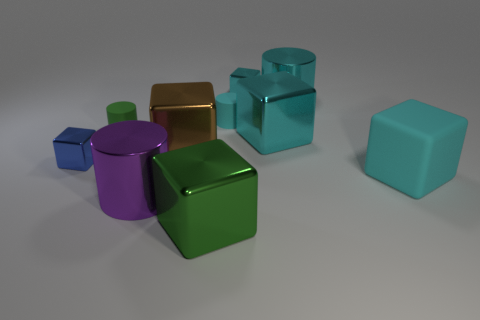Is the number of large metal cubes that are right of the green metal thing greater than the number of brown blocks behind the brown metallic object?
Your answer should be compact. Yes. There is a rubber cylinder that is the same color as the big rubber thing; what is its size?
Your answer should be compact. Small. Do the green cube and the cyan block in front of the brown metal block have the same size?
Your answer should be very brief. Yes. What number of cylinders are cyan metal things or big matte things?
Make the answer very short. 1. There is a blue object that is made of the same material as the purple cylinder; what is its size?
Offer a terse response. Small. Is the size of the cyan rubber object that is behind the big matte cube the same as the matte cylinder on the left side of the big brown block?
Keep it short and to the point. Yes. How many objects are big cyan cylinders or metallic blocks?
Provide a succinct answer. 6. There is a blue metal object; what shape is it?
Your answer should be compact. Cube. The cyan rubber object that is the same shape as the small green thing is what size?
Provide a succinct answer. Small. How big is the metallic thing left of the shiny cylinder in front of the large cyan matte block?
Your answer should be very brief. Small. 